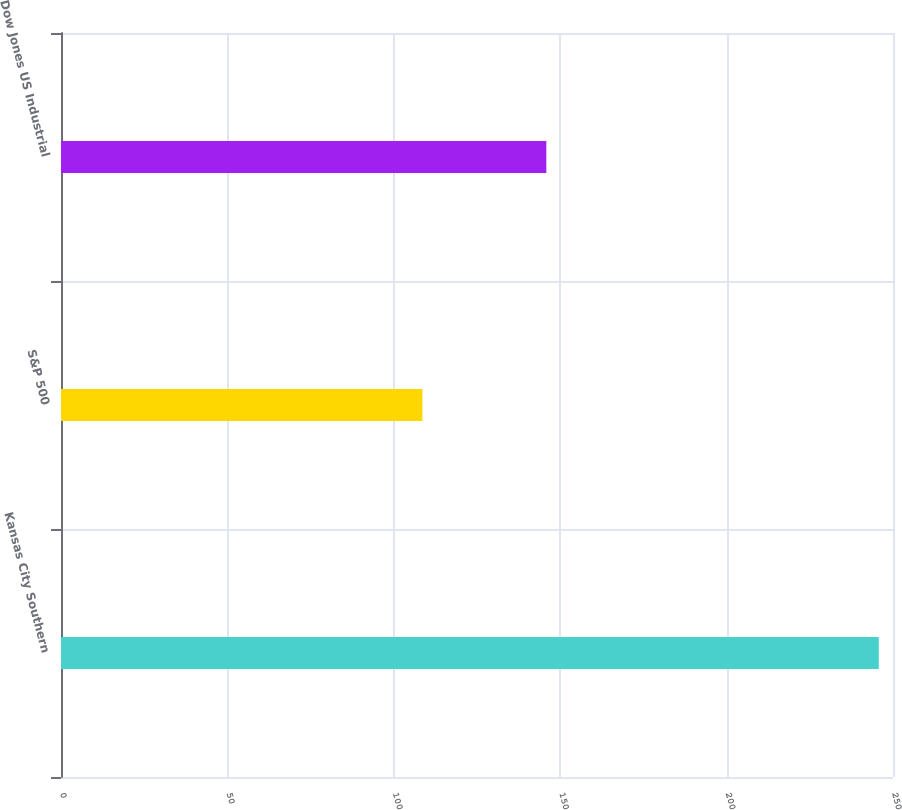Convert chart. <chart><loc_0><loc_0><loc_500><loc_500><bar_chart><fcel>Kansas City Southern<fcel>S&P 500<fcel>Dow Jones US Industrial<nl><fcel>245.74<fcel>108.59<fcel>145.83<nl></chart> 